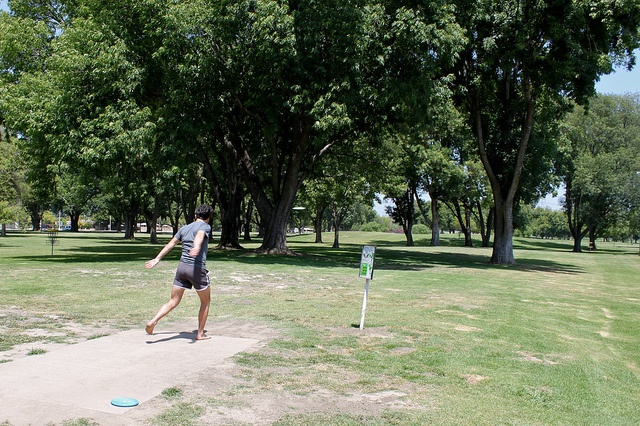Describe the objects in this image and their specific colors. I can see people in lightblue, black, lightgray, brown, and darkgray tones, frisbee in lightblue, blue, and gray tones, and frisbee in lightblue, white, teal, black, and darkgray tones in this image. 